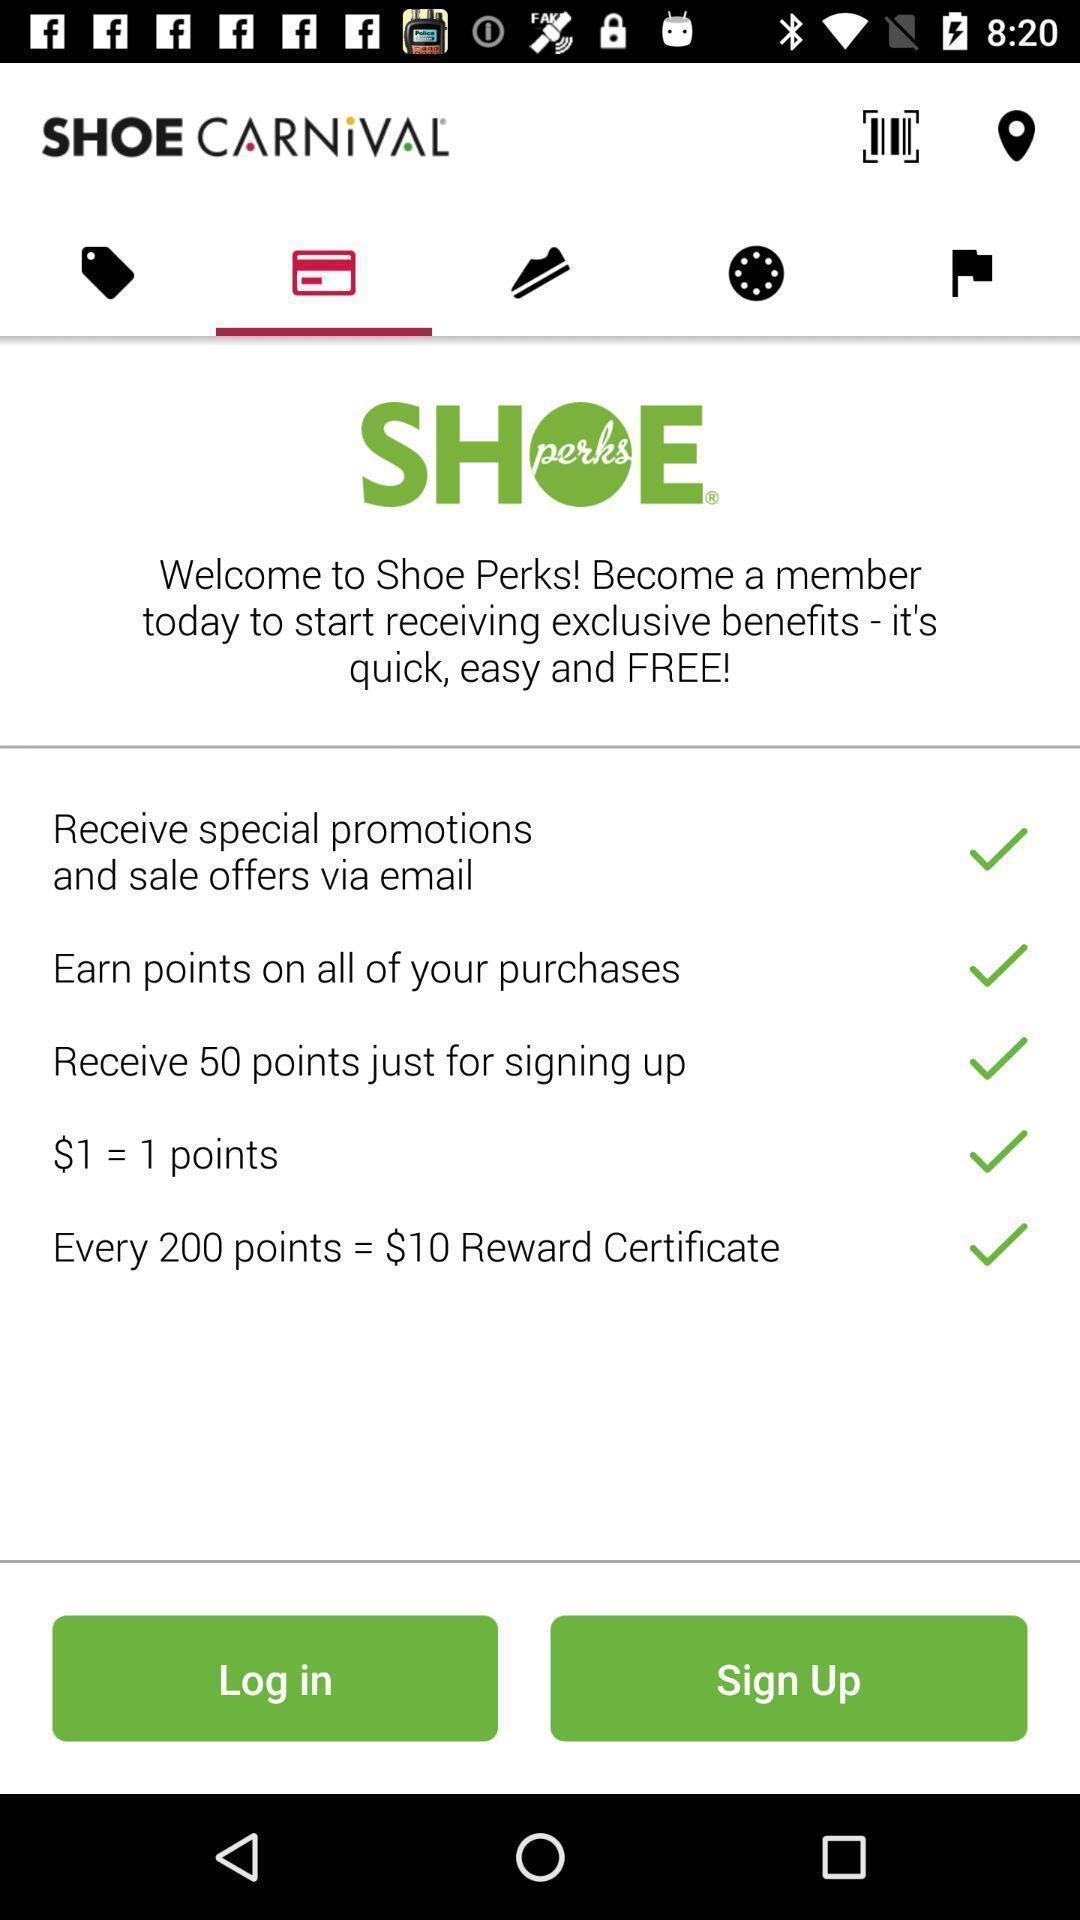Describe the visual elements of this screenshot. Login page for the social app. 